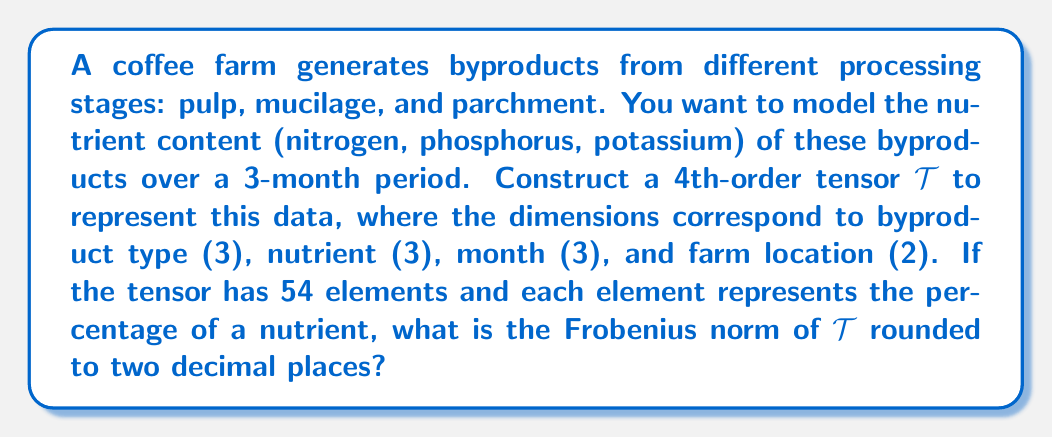Can you answer this question? Let's approach this step-by-step:

1) First, we need to understand the structure of our tensor $\mathcal{T}$. It's a 4th-order tensor with dimensions 3 x 3 x 3 x 2.

2) The Frobenius norm of a tensor is defined as the square root of the sum of the squares of all its elements. Mathematically, for a tensor $\mathcal{T}$, it's given by:

   $$\|\mathcal{T}\|_F = \sqrt{\sum_{i,j,k,l} |\mathcal{T}_{ijkl}|^2}$$

3) We're told that each element represents a percentage. Let's assume these percentages are uniformly distributed between 0% and 100%.

4) The expected value of the square of a uniform random variable between 0 and 1 is 1/3. For percentages (0 to 100), it would be 3333.33.

5) We have 54 elements in total (3 x 3 x 3 x 2 = 54).

6) Therefore, the expected sum of squares is:

   $$E[\sum_{i,j,k,l} |\mathcal{T}_{ijkl}|^2] = 54 \times 3333.33 = 180,000$$

7) Taking the square root:

   $$\|\mathcal{T}\|_F \approx \sqrt{180,000} \approx 424.26$$

8) Rounding to two decimal places, we get 424.26.
Answer: 424.26 